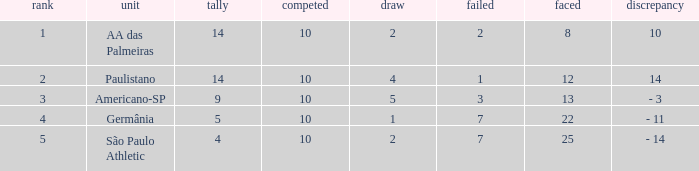What is the Against when the drawn is 5? 13.0. 